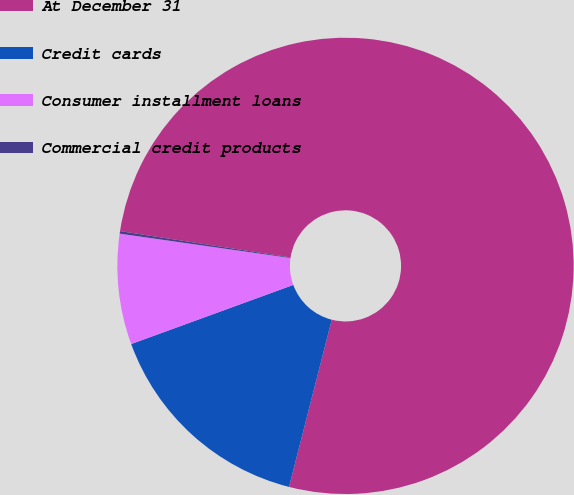Convert chart. <chart><loc_0><loc_0><loc_500><loc_500><pie_chart><fcel>At December 31<fcel>Credit cards<fcel>Consumer installment loans<fcel>Commercial credit products<nl><fcel>76.54%<fcel>15.45%<fcel>7.82%<fcel>0.18%<nl></chart> 